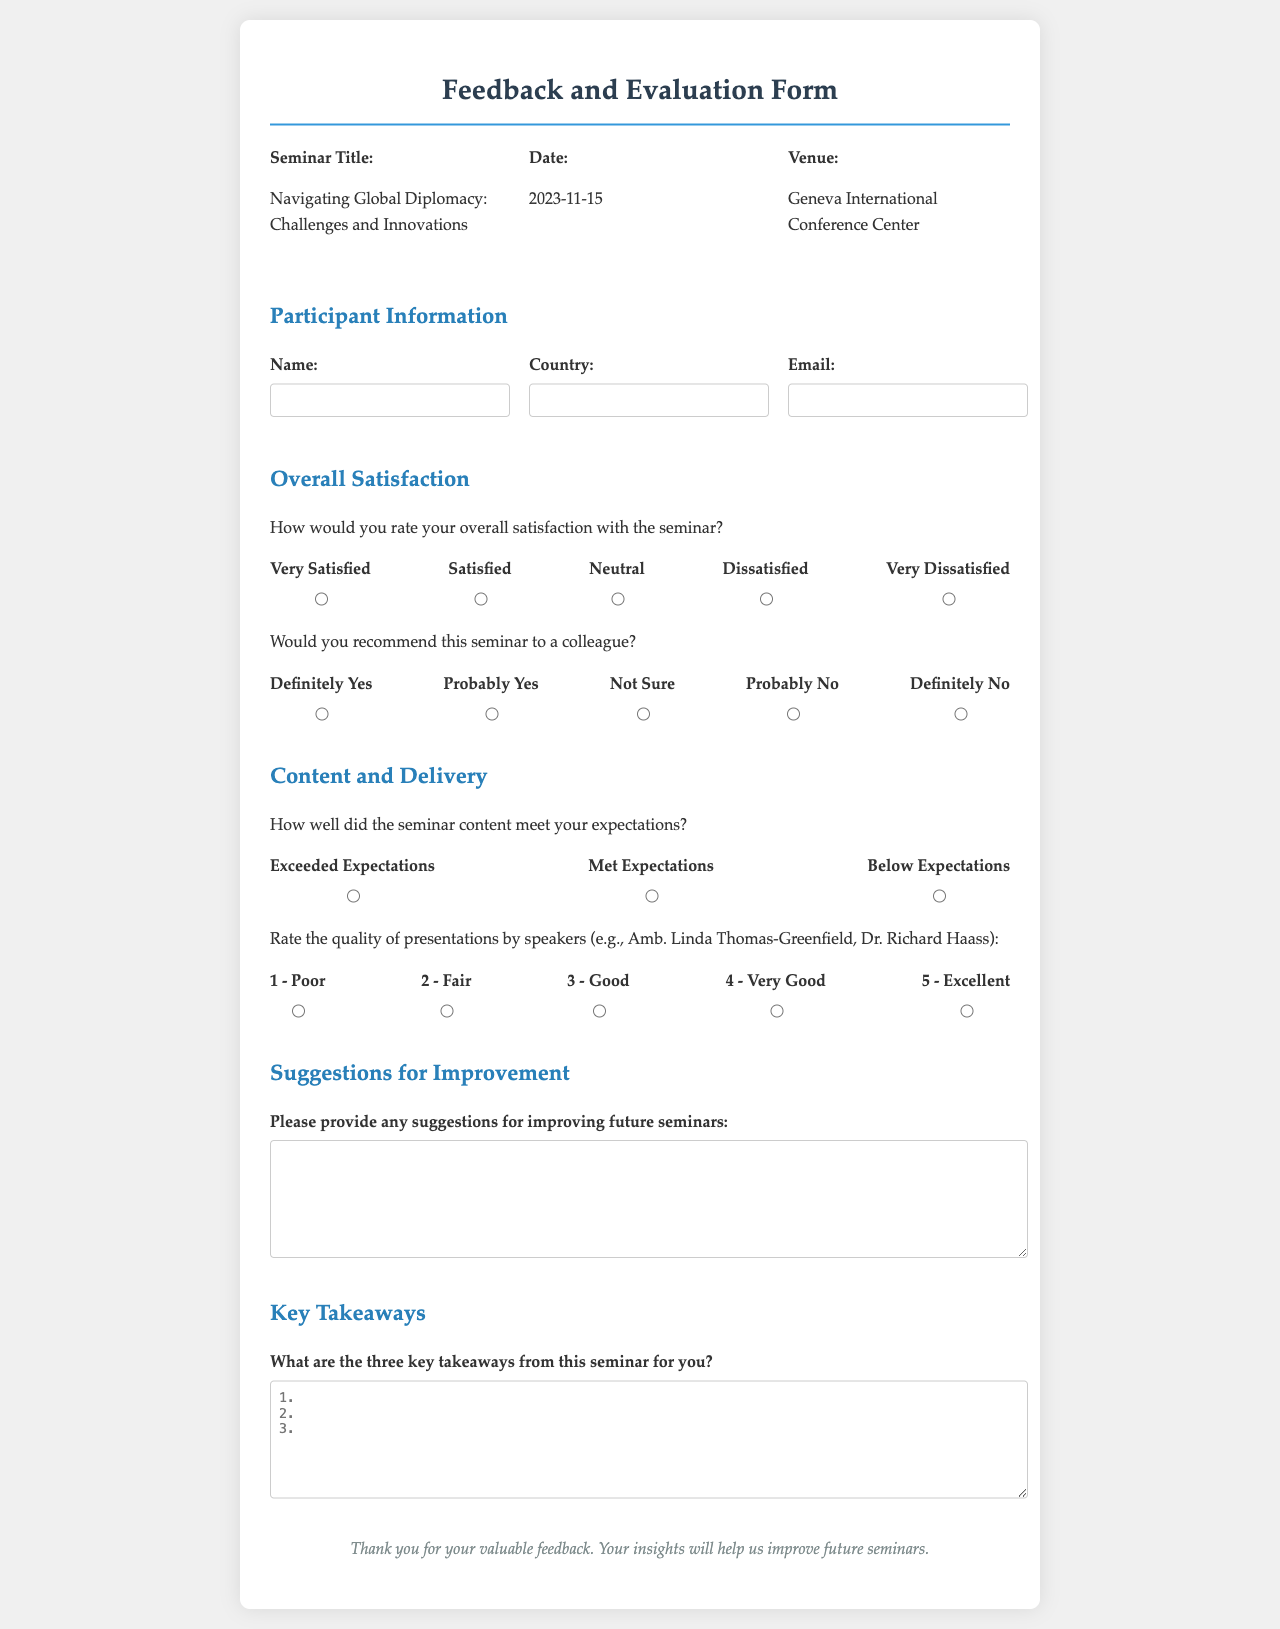What is the title of the seminar? The title is specifically mentioned in the document, focusing on the subject of the seminar.
Answer: Navigating Global Diplomacy: Challenges and Innovations On what date is the seminar scheduled? The seminar date is explicitly stated in the document, providing a clear timeframe for the event.
Answer: 2023-11-15 Where is the venue of the seminar? The document identifies the location for the seminar, indicating where the event will take place.
Answer: Geneva International Conference Center How would you rate your overall satisfaction with the seminar? This question looks for a specific response option from the satisfaction rating section of the document.
Answer: (Participant specific response) What are the three key takeaways from this seminar for you? This question prompts the participant to identify significant insights gained from the seminar, as outlined in the takeaways section.
Answer: (Participant specific response) What is the rating scale for the quality of presentations by speakers? The document lists the rating scale by which participants can evaluate presentation quality, detailing categories and corresponding numbers.
Answer: 1 - Poor to 5 - Excellent How many options are there for recommending the seminar to a colleague? The recommendation section presents a range of options for participants to express their willingness to recommend the seminar.
Answer: Five options What suggestions can participants provide for future seminars? This asks for input from the suggestions section, focusing on improvements voiced by participants.
Answer: (Participant specific response) 